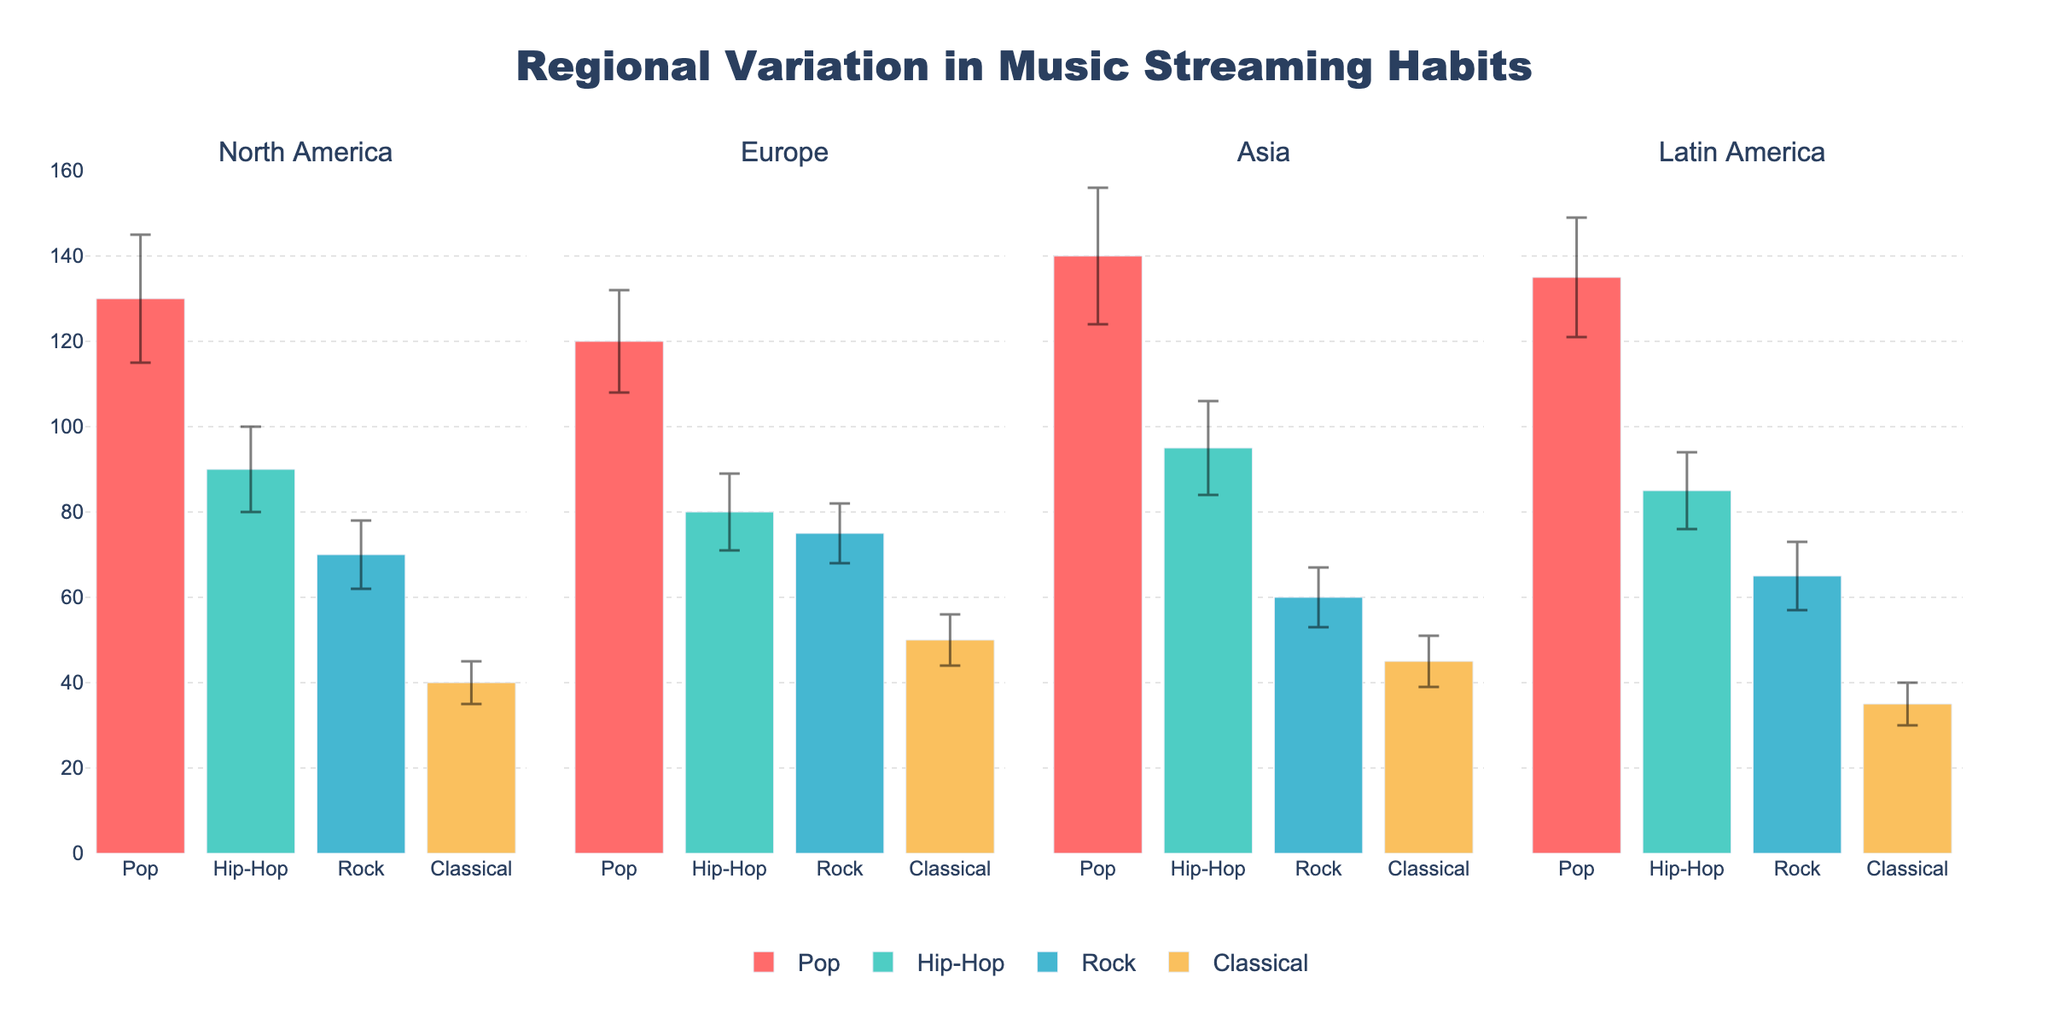What's the title of the figure? The title is prominently displayed at the top of the figure. It provides a summary of what the figure is about.
Answer: Regional Variation in Music Streaming Habits Which region has the highest mean listening hours for Pop? By analyzing the bars for the Pop genre in each region, the tallest bar represents the highest mean listening hours.
Answer: Asia What is the range of the y-axis? The y-axis range, which indicates the span of values it covers, can be observed on the left side of the figure.
Answer: 0 to 160 Which genre in Europe has the smallest standard deviation? By examining the error bars in the Europe subplot, the shortest error bar indicates the smallest standard deviation.
Answer: Classical Compare the mean listening hours for Rock between North America and Latin America. By comparing the heights of the Rock bars for North America and Latin America, we determine which values are higher or lower.
Answer: North America's mean listening hours are higher at 70, compared to Latin America's 65 How much higher are the mean listening hours for Hip-Hop in Asia compared to Europe? By subtracting Europe's mean listening hours for Hip-Hop from Asia's mean listening hours for Hip-Hop, we can find the difference.
Answer: 15 hours Which region shows the most variability in Pop listening hours? The region with the largest error bar for the Pop genre indicates the greatest variability, as the error bar represents the standard deviation.
Answer: Asia What genre in Latin America has the least mean listening hours? Analyzing the height of the bars for each genre in Latin America, the shortest bar represents the least mean listening hours.
Answer: Classical What is the sum of mean listening hours for Classical music across all regions? Summing up the mean listening hours for Classical music from each region: 40 (NA) + 50 (Europe) + 45 (Asia) + 35 (LA).
Answer: 170 hours For which genre does North America have the highest listening mean in its region, and what is it? By comparing all genres within the North America subplot, the tallest bar gives the genre and its mean value.
Answer: Pop, 130 hours 